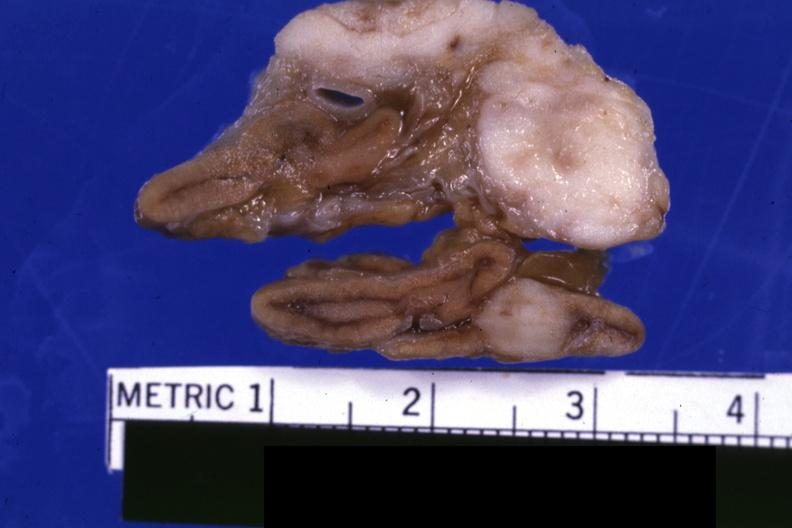s mesentery present?
Answer the question using a single word or phrase. No 